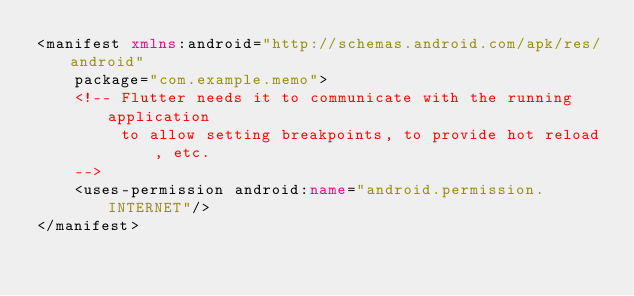<code> <loc_0><loc_0><loc_500><loc_500><_XML_><manifest xmlns:android="http://schemas.android.com/apk/res/android"
    package="com.example.memo">
    <!-- Flutter needs it to communicate with the running application
         to allow setting breakpoints, to provide hot reload, etc.
    -->
    <uses-permission android:name="android.permission.INTERNET"/>
</manifest>
</code> 